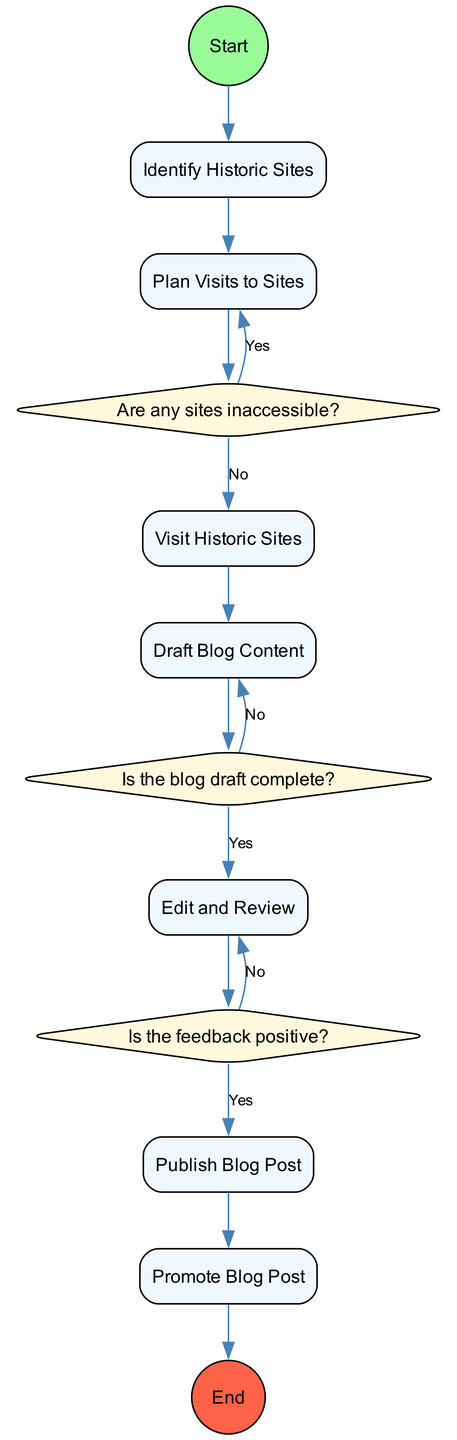What is the first activity in the diagram? The diagram starts with the node labeled "Start," which then leads to the first activity labeled "Identify Historic Sites."
Answer: Identify Historic Sites How many main activities are there? There is a count of the nodes labeled as activities in the diagram. The activities listed are: Identify Historic Sites, Plan Visits to Sites, Visit Historic Sites, Draft Blog Content, Edit and Review, Publish Blog Post, and Promote Blog Post. This totals to seven main activities.
Answer: 7 What decision point occurs after planning visits? After planning visits, the decision point is labeled "Are any sites inaccessible?" which is critical in determining how to proceed with the visits.
Answer: Are any sites inaccessible? Which activity directly follows the decision point "Is the feedback positive?" After the decision point "Is the feedback positive?", if the answer is yes, the next activity is "Publish Blog Post."
Answer: Publish Blog Post What action is taken if there are inaccessible sites? If there are inaccessible sites, the action taken is to "Remove the site from the list," as indicated in the diagram.
Answer: Remove the site from the list Which node leads to the end of the process? The node that leads to the end of the process is labeled "End," and it is reached after completing the promotions of the blog post, following the "Promote Blog Post" activity.
Answer: End What happens if the blog draft is not complete? If the blog draft is not complete, the flow returns to the "Draft Blog Content" activity, indicating the need to continue working on the draft.
Answer: Continue drafting the content Which activity has the most actions listed? The activity with the most actions listed is "Draft Blog Content," with four specific actions outlined to guide the writing process.
Answer: Draft Blog Content What is the relationship between the "Visit Historic Sites" activity and "Draft Blog Content"? The "Visit Historic Sites" activity leads directly to the "Draft Blog Content" activity, indicating that the content is drafted after visiting the sites.
Answer: Leads directly to What type of diagram is being described? The diagram described is an Activity Diagram, which illustrates the workflow of writing and publishing a blog about Winnipeg's historic sites through various activities and decision points.
Answer: Activity Diagram 